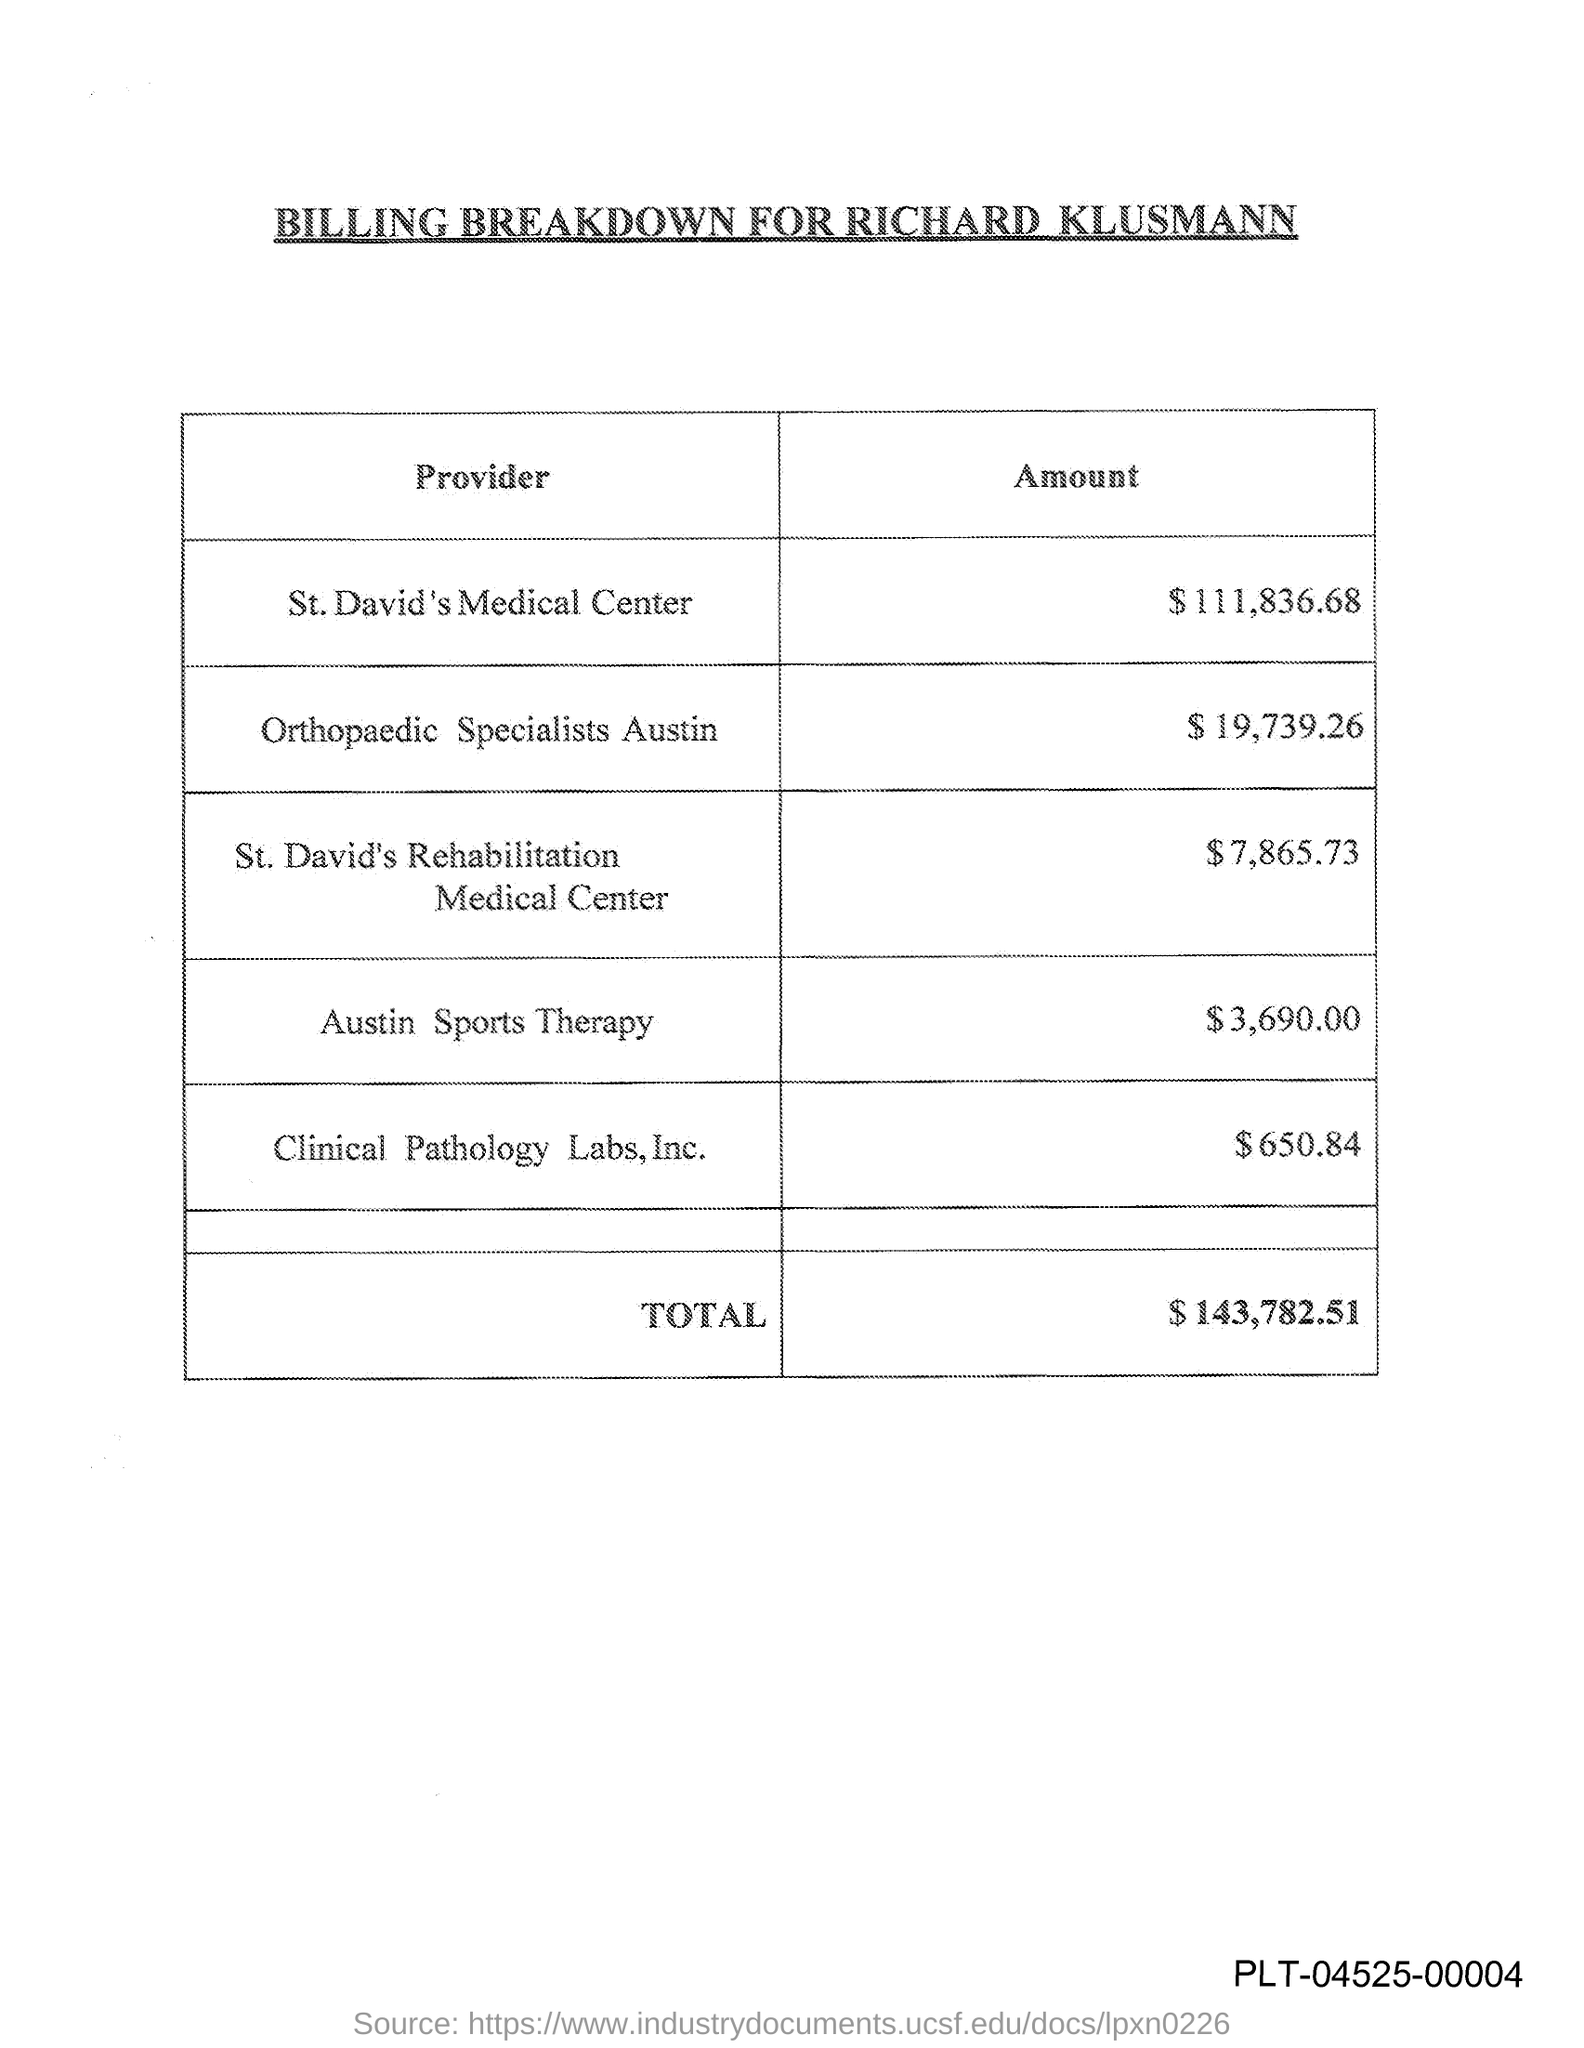What is the title of the document?
Offer a very short reply. Billing Breakdown for Richard Klusmann. What is the total amount?
Keep it short and to the point. 143,782.51. 